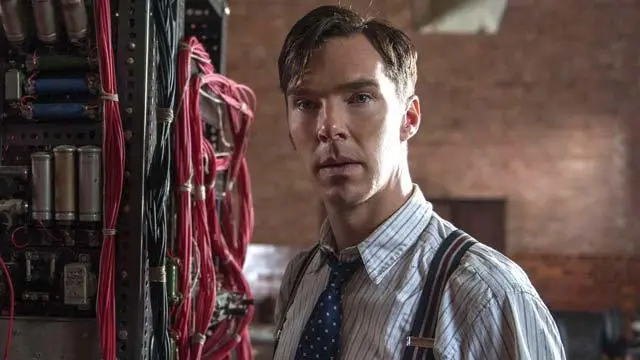Can you tell me more about the machine shown in the image? What might it represent? The machine in the image, filled with a multitude of red wires and silver cylindrical components, appears to be an early or stylized version of a computer or a complex decoding device, possibly representing an invention or tool critical to the narrative. Its intricate design and prominent placement suggest its importance in the depicted activities, possibly symbolizing innovation, intelligence operations, or scientific research in a historic context. 